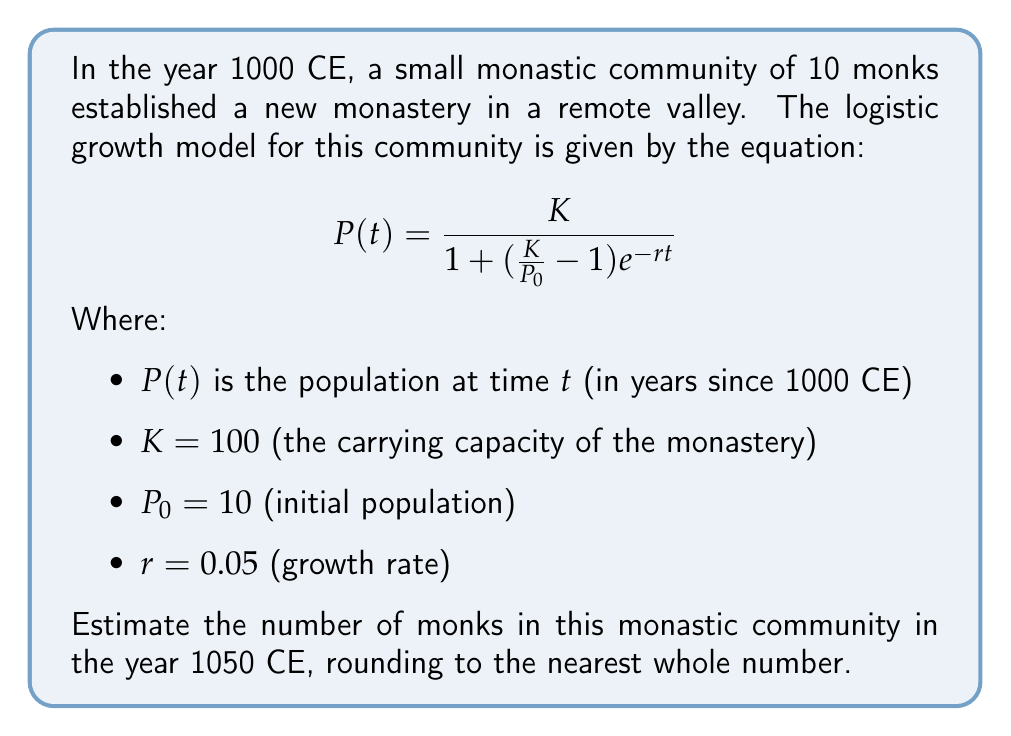What is the answer to this math problem? To solve this problem, we'll follow these steps:

1) First, we need to identify the values for our equation:
   $K = 100$
   $P_0 = 10$
   $r = 0.05$
   $t = 50$ (as we're calculating for 1050 CE, which is 50 years after 1000 CE)

2) Now, let's substitute these values into our logistic growth equation:

   $$P(50) = \frac{100}{1 + (\frac{100}{10} - 1)e^{-0.05(50)}}$$

3) Simplify the fraction inside the parentheses:
   
   $$P(50) = \frac{100}{1 + (10 - 1)e^{-2.5}}$$

4) Simplify further:

   $$P(50) = \frac{100}{1 + 9e^{-2.5}}$$

5) Calculate $e^{-2.5}$:
   
   $e^{-2.5} \approx 0.0821$

6) Multiply:
   
   $$P(50) = \frac{100}{1 + 9(0.0821)} = \frac{100}{1 + 0.7389}$$

7) Simplify:

   $$P(50) = \frac{100}{1.7389} \approx 57.5074$$

8) Rounding to the nearest whole number:

   $P(50) \approx 58$

Therefore, the estimated number of monks in the year 1050 CE is 58.
Answer: 58 monks 